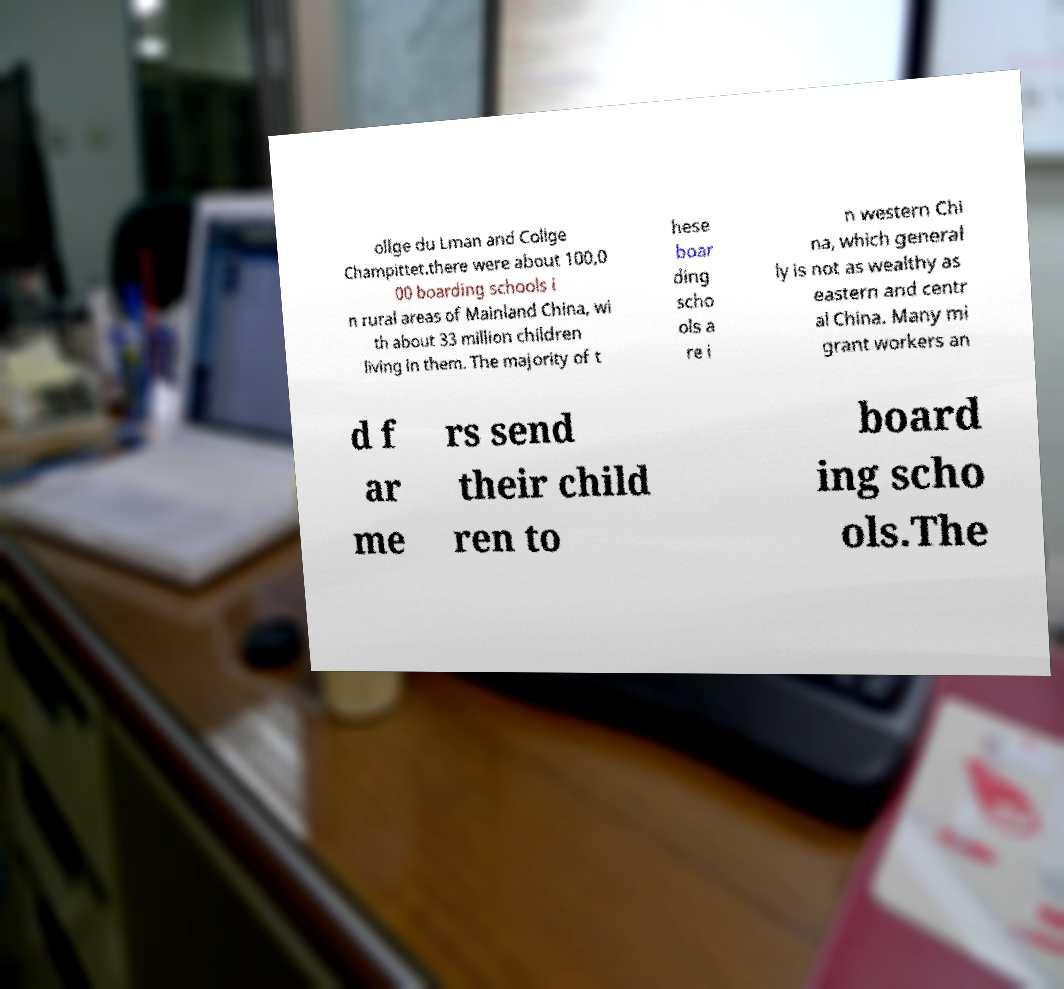There's text embedded in this image that I need extracted. Can you transcribe it verbatim? ollge du Lman and Collge Champittet.there were about 100,0 00 boarding schools i n rural areas of Mainland China, wi th about 33 million children living in them. The majority of t hese boar ding scho ols a re i n western Chi na, which general ly is not as wealthy as eastern and centr al China. Many mi grant workers an d f ar me rs send their child ren to board ing scho ols.The 